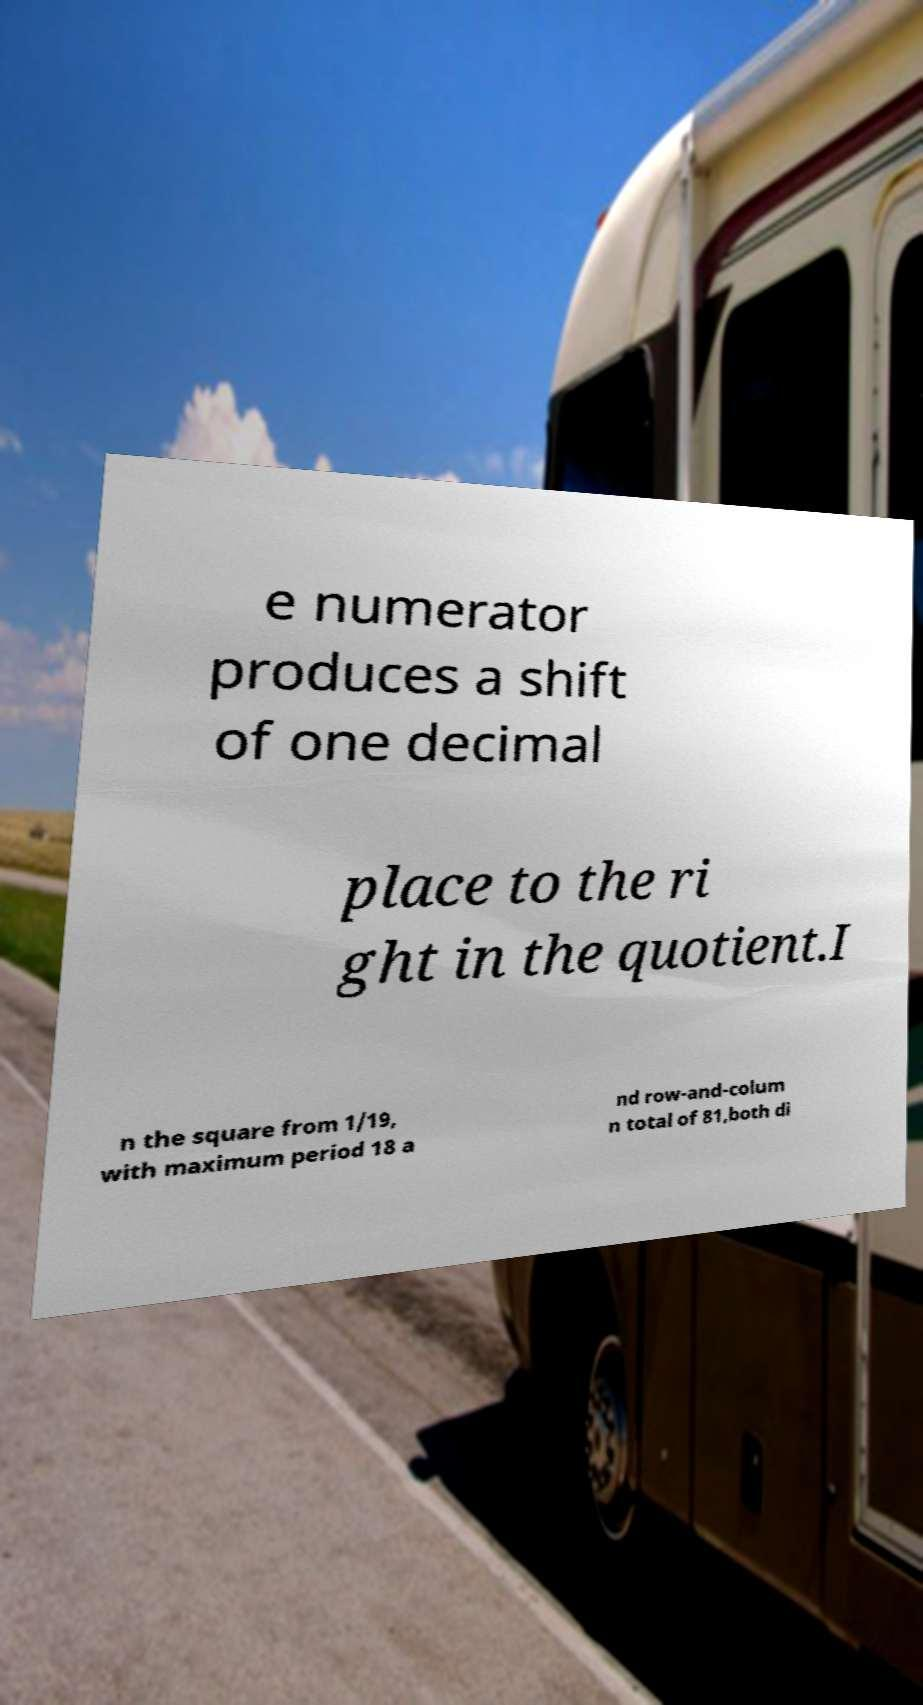I need the written content from this picture converted into text. Can you do that? e numerator produces a shift of one decimal place to the ri ght in the quotient.I n the square from 1/19, with maximum period 18 a nd row-and-colum n total of 81,both di 